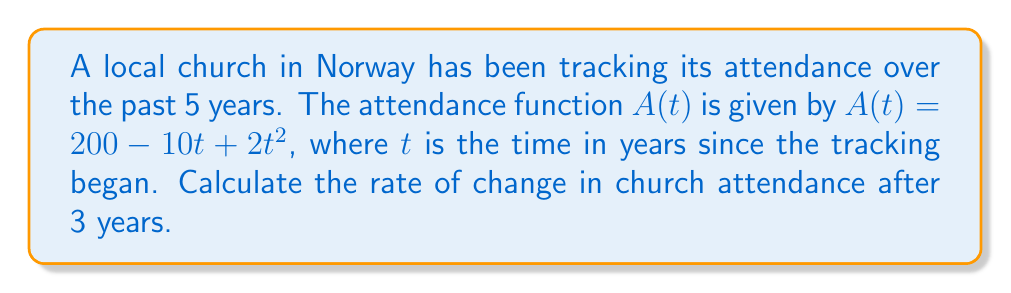Could you help me with this problem? To find the rate of change in church attendance after 3 years, we need to calculate the derivative of the attendance function $A(t)$ and evaluate it at $t=3$.

Step 1: Find the derivative of $A(t)$.
$$\frac{d}{dt}A(t) = \frac{d}{dt}(200 - 10t + 2t^2)$$
$$A'(t) = 0 - 10 + 4t$$
$$A'(t) = -10 + 4t$$

Step 2: Evaluate the derivative at $t=3$.
$$A'(3) = -10 + 4(3)$$
$$A'(3) = -10 + 12$$
$$A'(3) = 2$$

The rate of change after 3 years is 2 people per year.

Step 3: Interpret the result.
A positive rate of change indicates that the church attendance is increasing at this point in time. Specifically, it is increasing by 2 people per year after 3 years.
Answer: $2$ people/year 